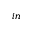Convert formula to latex. <formula><loc_0><loc_0><loc_500><loc_500>_ { i n }</formula> 